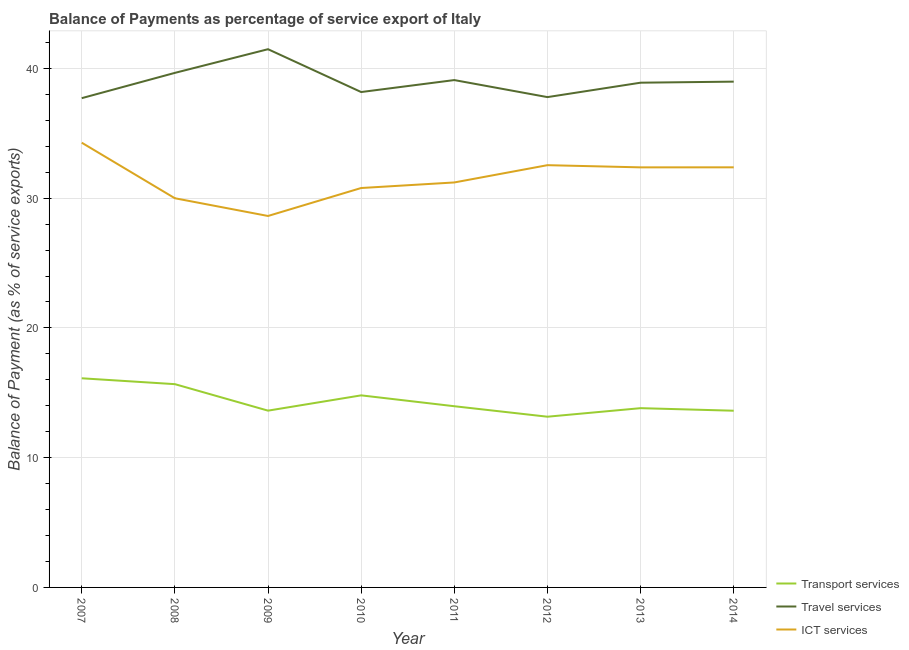Does the line corresponding to balance of payment of travel services intersect with the line corresponding to balance of payment of ict services?
Give a very brief answer. No. Is the number of lines equal to the number of legend labels?
Your response must be concise. Yes. What is the balance of payment of ict services in 2011?
Make the answer very short. 31.21. Across all years, what is the maximum balance of payment of transport services?
Your answer should be compact. 16.12. Across all years, what is the minimum balance of payment of transport services?
Offer a very short reply. 13.16. What is the total balance of payment of ict services in the graph?
Make the answer very short. 252.18. What is the difference between the balance of payment of ict services in 2009 and that in 2010?
Your answer should be very brief. -2.16. What is the difference between the balance of payment of transport services in 2007 and the balance of payment of travel services in 2014?
Offer a very short reply. -22.86. What is the average balance of payment of transport services per year?
Provide a short and direct response. 14.35. In the year 2014, what is the difference between the balance of payment of travel services and balance of payment of transport services?
Offer a terse response. 25.36. In how many years, is the balance of payment of ict services greater than 22 %?
Keep it short and to the point. 8. What is the ratio of the balance of payment of transport services in 2009 to that in 2014?
Give a very brief answer. 1. Is the difference between the balance of payment of transport services in 2008 and 2012 greater than the difference between the balance of payment of travel services in 2008 and 2012?
Provide a short and direct response. Yes. What is the difference between the highest and the second highest balance of payment of ict services?
Ensure brevity in your answer.  1.73. What is the difference between the highest and the lowest balance of payment of travel services?
Make the answer very short. 3.77. Is the sum of the balance of payment of ict services in 2010 and 2014 greater than the maximum balance of payment of travel services across all years?
Give a very brief answer. Yes. Does the balance of payment of ict services monotonically increase over the years?
Ensure brevity in your answer.  No. Is the balance of payment of ict services strictly less than the balance of payment of travel services over the years?
Offer a terse response. Yes. Does the graph contain grids?
Give a very brief answer. Yes. Where does the legend appear in the graph?
Your response must be concise. Bottom right. How many legend labels are there?
Your answer should be very brief. 3. What is the title of the graph?
Keep it short and to the point. Balance of Payments as percentage of service export of Italy. What is the label or title of the X-axis?
Give a very brief answer. Year. What is the label or title of the Y-axis?
Provide a short and direct response. Balance of Payment (as % of service exports). What is the Balance of Payment (as % of service exports) of Transport services in 2007?
Your answer should be very brief. 16.12. What is the Balance of Payment (as % of service exports) in Travel services in 2007?
Offer a very short reply. 37.71. What is the Balance of Payment (as % of service exports) of ICT services in 2007?
Make the answer very short. 34.28. What is the Balance of Payment (as % of service exports) of Transport services in 2008?
Provide a short and direct response. 15.67. What is the Balance of Payment (as % of service exports) in Travel services in 2008?
Your answer should be compact. 39.66. What is the Balance of Payment (as % of service exports) in ICT services in 2008?
Provide a succinct answer. 29.99. What is the Balance of Payment (as % of service exports) of Transport services in 2009?
Your answer should be compact. 13.62. What is the Balance of Payment (as % of service exports) of Travel services in 2009?
Give a very brief answer. 41.48. What is the Balance of Payment (as % of service exports) of ICT services in 2009?
Keep it short and to the point. 28.63. What is the Balance of Payment (as % of service exports) in Transport services in 2010?
Your response must be concise. 14.8. What is the Balance of Payment (as % of service exports) of Travel services in 2010?
Make the answer very short. 38.18. What is the Balance of Payment (as % of service exports) of ICT services in 2010?
Provide a short and direct response. 30.78. What is the Balance of Payment (as % of service exports) of Transport services in 2011?
Offer a terse response. 13.96. What is the Balance of Payment (as % of service exports) of Travel services in 2011?
Make the answer very short. 39.1. What is the Balance of Payment (as % of service exports) in ICT services in 2011?
Your answer should be compact. 31.21. What is the Balance of Payment (as % of service exports) in Transport services in 2012?
Provide a short and direct response. 13.16. What is the Balance of Payment (as % of service exports) in Travel services in 2012?
Your answer should be compact. 37.79. What is the Balance of Payment (as % of service exports) of ICT services in 2012?
Your answer should be compact. 32.54. What is the Balance of Payment (as % of service exports) in Transport services in 2013?
Your response must be concise. 13.82. What is the Balance of Payment (as % of service exports) in Travel services in 2013?
Ensure brevity in your answer.  38.9. What is the Balance of Payment (as % of service exports) in ICT services in 2013?
Keep it short and to the point. 32.37. What is the Balance of Payment (as % of service exports) in Transport services in 2014?
Keep it short and to the point. 13.62. What is the Balance of Payment (as % of service exports) in Travel services in 2014?
Your answer should be very brief. 38.98. What is the Balance of Payment (as % of service exports) of ICT services in 2014?
Offer a very short reply. 32.38. Across all years, what is the maximum Balance of Payment (as % of service exports) of Transport services?
Make the answer very short. 16.12. Across all years, what is the maximum Balance of Payment (as % of service exports) of Travel services?
Make the answer very short. 41.48. Across all years, what is the maximum Balance of Payment (as % of service exports) of ICT services?
Your answer should be compact. 34.28. Across all years, what is the minimum Balance of Payment (as % of service exports) in Transport services?
Your response must be concise. 13.16. Across all years, what is the minimum Balance of Payment (as % of service exports) of Travel services?
Give a very brief answer. 37.71. Across all years, what is the minimum Balance of Payment (as % of service exports) in ICT services?
Give a very brief answer. 28.63. What is the total Balance of Payment (as % of service exports) in Transport services in the graph?
Give a very brief answer. 114.77. What is the total Balance of Payment (as % of service exports) in Travel services in the graph?
Offer a very short reply. 311.79. What is the total Balance of Payment (as % of service exports) in ICT services in the graph?
Your response must be concise. 252.18. What is the difference between the Balance of Payment (as % of service exports) in Transport services in 2007 and that in 2008?
Make the answer very short. 0.45. What is the difference between the Balance of Payment (as % of service exports) of Travel services in 2007 and that in 2008?
Provide a succinct answer. -1.95. What is the difference between the Balance of Payment (as % of service exports) in ICT services in 2007 and that in 2008?
Your answer should be very brief. 4.28. What is the difference between the Balance of Payment (as % of service exports) of Transport services in 2007 and that in 2009?
Your answer should be very brief. 2.49. What is the difference between the Balance of Payment (as % of service exports) in Travel services in 2007 and that in 2009?
Ensure brevity in your answer.  -3.77. What is the difference between the Balance of Payment (as % of service exports) of ICT services in 2007 and that in 2009?
Your response must be concise. 5.65. What is the difference between the Balance of Payment (as % of service exports) in Transport services in 2007 and that in 2010?
Your answer should be very brief. 1.32. What is the difference between the Balance of Payment (as % of service exports) in Travel services in 2007 and that in 2010?
Your answer should be very brief. -0.47. What is the difference between the Balance of Payment (as % of service exports) in ICT services in 2007 and that in 2010?
Ensure brevity in your answer.  3.49. What is the difference between the Balance of Payment (as % of service exports) of Transport services in 2007 and that in 2011?
Offer a terse response. 2.15. What is the difference between the Balance of Payment (as % of service exports) in Travel services in 2007 and that in 2011?
Provide a short and direct response. -1.39. What is the difference between the Balance of Payment (as % of service exports) in ICT services in 2007 and that in 2011?
Offer a terse response. 3.06. What is the difference between the Balance of Payment (as % of service exports) in Transport services in 2007 and that in 2012?
Offer a very short reply. 2.96. What is the difference between the Balance of Payment (as % of service exports) in Travel services in 2007 and that in 2012?
Give a very brief answer. -0.08. What is the difference between the Balance of Payment (as % of service exports) in ICT services in 2007 and that in 2012?
Make the answer very short. 1.73. What is the difference between the Balance of Payment (as % of service exports) of Transport services in 2007 and that in 2013?
Offer a very short reply. 2.3. What is the difference between the Balance of Payment (as % of service exports) of Travel services in 2007 and that in 2013?
Your answer should be compact. -1.19. What is the difference between the Balance of Payment (as % of service exports) of ICT services in 2007 and that in 2013?
Your answer should be very brief. 1.9. What is the difference between the Balance of Payment (as % of service exports) in Transport services in 2007 and that in 2014?
Your answer should be very brief. 2.5. What is the difference between the Balance of Payment (as % of service exports) of Travel services in 2007 and that in 2014?
Provide a short and direct response. -1.27. What is the difference between the Balance of Payment (as % of service exports) in ICT services in 2007 and that in 2014?
Give a very brief answer. 1.9. What is the difference between the Balance of Payment (as % of service exports) in Transport services in 2008 and that in 2009?
Your answer should be very brief. 2.04. What is the difference between the Balance of Payment (as % of service exports) in Travel services in 2008 and that in 2009?
Your response must be concise. -1.82. What is the difference between the Balance of Payment (as % of service exports) in ICT services in 2008 and that in 2009?
Offer a very short reply. 1.37. What is the difference between the Balance of Payment (as % of service exports) of Transport services in 2008 and that in 2010?
Make the answer very short. 0.86. What is the difference between the Balance of Payment (as % of service exports) in Travel services in 2008 and that in 2010?
Offer a terse response. 1.48. What is the difference between the Balance of Payment (as % of service exports) of ICT services in 2008 and that in 2010?
Offer a very short reply. -0.79. What is the difference between the Balance of Payment (as % of service exports) of Transport services in 2008 and that in 2011?
Your answer should be compact. 1.7. What is the difference between the Balance of Payment (as % of service exports) in Travel services in 2008 and that in 2011?
Offer a terse response. 0.56. What is the difference between the Balance of Payment (as % of service exports) of ICT services in 2008 and that in 2011?
Provide a succinct answer. -1.22. What is the difference between the Balance of Payment (as % of service exports) of Transport services in 2008 and that in 2012?
Make the answer very short. 2.51. What is the difference between the Balance of Payment (as % of service exports) of Travel services in 2008 and that in 2012?
Provide a succinct answer. 1.87. What is the difference between the Balance of Payment (as % of service exports) in ICT services in 2008 and that in 2012?
Ensure brevity in your answer.  -2.55. What is the difference between the Balance of Payment (as % of service exports) of Transport services in 2008 and that in 2013?
Provide a succinct answer. 1.85. What is the difference between the Balance of Payment (as % of service exports) in Travel services in 2008 and that in 2013?
Ensure brevity in your answer.  0.76. What is the difference between the Balance of Payment (as % of service exports) in ICT services in 2008 and that in 2013?
Make the answer very short. -2.38. What is the difference between the Balance of Payment (as % of service exports) of Transport services in 2008 and that in 2014?
Ensure brevity in your answer.  2.05. What is the difference between the Balance of Payment (as % of service exports) of Travel services in 2008 and that in 2014?
Ensure brevity in your answer.  0.68. What is the difference between the Balance of Payment (as % of service exports) of ICT services in 2008 and that in 2014?
Offer a very short reply. -2.38. What is the difference between the Balance of Payment (as % of service exports) in Transport services in 2009 and that in 2010?
Offer a terse response. -1.18. What is the difference between the Balance of Payment (as % of service exports) in Travel services in 2009 and that in 2010?
Offer a very short reply. 3.3. What is the difference between the Balance of Payment (as % of service exports) of ICT services in 2009 and that in 2010?
Offer a terse response. -2.16. What is the difference between the Balance of Payment (as % of service exports) in Transport services in 2009 and that in 2011?
Ensure brevity in your answer.  -0.34. What is the difference between the Balance of Payment (as % of service exports) of Travel services in 2009 and that in 2011?
Offer a very short reply. 2.38. What is the difference between the Balance of Payment (as % of service exports) of ICT services in 2009 and that in 2011?
Make the answer very short. -2.58. What is the difference between the Balance of Payment (as % of service exports) in Transport services in 2009 and that in 2012?
Keep it short and to the point. 0.47. What is the difference between the Balance of Payment (as % of service exports) of Travel services in 2009 and that in 2012?
Provide a succinct answer. 3.69. What is the difference between the Balance of Payment (as % of service exports) of ICT services in 2009 and that in 2012?
Give a very brief answer. -3.92. What is the difference between the Balance of Payment (as % of service exports) in Transport services in 2009 and that in 2013?
Make the answer very short. -0.19. What is the difference between the Balance of Payment (as % of service exports) of Travel services in 2009 and that in 2013?
Keep it short and to the point. 2.58. What is the difference between the Balance of Payment (as % of service exports) of ICT services in 2009 and that in 2013?
Provide a succinct answer. -3.75. What is the difference between the Balance of Payment (as % of service exports) of Transport services in 2009 and that in 2014?
Provide a short and direct response. 0.01. What is the difference between the Balance of Payment (as % of service exports) in Travel services in 2009 and that in 2014?
Provide a short and direct response. 2.5. What is the difference between the Balance of Payment (as % of service exports) of ICT services in 2009 and that in 2014?
Your response must be concise. -3.75. What is the difference between the Balance of Payment (as % of service exports) in Transport services in 2010 and that in 2011?
Keep it short and to the point. 0.84. What is the difference between the Balance of Payment (as % of service exports) in Travel services in 2010 and that in 2011?
Give a very brief answer. -0.92. What is the difference between the Balance of Payment (as % of service exports) in ICT services in 2010 and that in 2011?
Offer a terse response. -0.43. What is the difference between the Balance of Payment (as % of service exports) of Transport services in 2010 and that in 2012?
Offer a terse response. 1.65. What is the difference between the Balance of Payment (as % of service exports) in Travel services in 2010 and that in 2012?
Provide a short and direct response. 0.39. What is the difference between the Balance of Payment (as % of service exports) of ICT services in 2010 and that in 2012?
Give a very brief answer. -1.76. What is the difference between the Balance of Payment (as % of service exports) in Transport services in 2010 and that in 2013?
Provide a short and direct response. 0.99. What is the difference between the Balance of Payment (as % of service exports) of Travel services in 2010 and that in 2013?
Your answer should be compact. -0.72. What is the difference between the Balance of Payment (as % of service exports) in ICT services in 2010 and that in 2013?
Your response must be concise. -1.59. What is the difference between the Balance of Payment (as % of service exports) in Transport services in 2010 and that in 2014?
Keep it short and to the point. 1.18. What is the difference between the Balance of Payment (as % of service exports) in Travel services in 2010 and that in 2014?
Provide a succinct answer. -0.8. What is the difference between the Balance of Payment (as % of service exports) in ICT services in 2010 and that in 2014?
Keep it short and to the point. -1.59. What is the difference between the Balance of Payment (as % of service exports) in Transport services in 2011 and that in 2012?
Your answer should be compact. 0.81. What is the difference between the Balance of Payment (as % of service exports) of Travel services in 2011 and that in 2012?
Ensure brevity in your answer.  1.31. What is the difference between the Balance of Payment (as % of service exports) in ICT services in 2011 and that in 2012?
Give a very brief answer. -1.33. What is the difference between the Balance of Payment (as % of service exports) in Transport services in 2011 and that in 2013?
Provide a succinct answer. 0.15. What is the difference between the Balance of Payment (as % of service exports) of Travel services in 2011 and that in 2013?
Offer a terse response. 0.2. What is the difference between the Balance of Payment (as % of service exports) of ICT services in 2011 and that in 2013?
Give a very brief answer. -1.16. What is the difference between the Balance of Payment (as % of service exports) in Transport services in 2011 and that in 2014?
Give a very brief answer. 0.35. What is the difference between the Balance of Payment (as % of service exports) of Travel services in 2011 and that in 2014?
Make the answer very short. 0.12. What is the difference between the Balance of Payment (as % of service exports) in ICT services in 2011 and that in 2014?
Keep it short and to the point. -1.17. What is the difference between the Balance of Payment (as % of service exports) of Transport services in 2012 and that in 2013?
Your response must be concise. -0.66. What is the difference between the Balance of Payment (as % of service exports) in Travel services in 2012 and that in 2013?
Provide a short and direct response. -1.11. What is the difference between the Balance of Payment (as % of service exports) of ICT services in 2012 and that in 2013?
Offer a very short reply. 0.17. What is the difference between the Balance of Payment (as % of service exports) of Transport services in 2012 and that in 2014?
Make the answer very short. -0.46. What is the difference between the Balance of Payment (as % of service exports) of Travel services in 2012 and that in 2014?
Offer a very short reply. -1.19. What is the difference between the Balance of Payment (as % of service exports) in ICT services in 2012 and that in 2014?
Offer a terse response. 0.17. What is the difference between the Balance of Payment (as % of service exports) in Transport services in 2013 and that in 2014?
Ensure brevity in your answer.  0.2. What is the difference between the Balance of Payment (as % of service exports) in Travel services in 2013 and that in 2014?
Your answer should be very brief. -0.08. What is the difference between the Balance of Payment (as % of service exports) in ICT services in 2013 and that in 2014?
Provide a short and direct response. -0. What is the difference between the Balance of Payment (as % of service exports) of Transport services in 2007 and the Balance of Payment (as % of service exports) of Travel services in 2008?
Provide a short and direct response. -23.54. What is the difference between the Balance of Payment (as % of service exports) of Transport services in 2007 and the Balance of Payment (as % of service exports) of ICT services in 2008?
Your answer should be very brief. -13.88. What is the difference between the Balance of Payment (as % of service exports) of Travel services in 2007 and the Balance of Payment (as % of service exports) of ICT services in 2008?
Ensure brevity in your answer.  7.71. What is the difference between the Balance of Payment (as % of service exports) of Transport services in 2007 and the Balance of Payment (as % of service exports) of Travel services in 2009?
Offer a very short reply. -25.36. What is the difference between the Balance of Payment (as % of service exports) of Transport services in 2007 and the Balance of Payment (as % of service exports) of ICT services in 2009?
Provide a succinct answer. -12.51. What is the difference between the Balance of Payment (as % of service exports) in Travel services in 2007 and the Balance of Payment (as % of service exports) in ICT services in 2009?
Offer a terse response. 9.08. What is the difference between the Balance of Payment (as % of service exports) of Transport services in 2007 and the Balance of Payment (as % of service exports) of Travel services in 2010?
Keep it short and to the point. -22.06. What is the difference between the Balance of Payment (as % of service exports) in Transport services in 2007 and the Balance of Payment (as % of service exports) in ICT services in 2010?
Offer a very short reply. -14.66. What is the difference between the Balance of Payment (as % of service exports) of Travel services in 2007 and the Balance of Payment (as % of service exports) of ICT services in 2010?
Offer a very short reply. 6.92. What is the difference between the Balance of Payment (as % of service exports) of Transport services in 2007 and the Balance of Payment (as % of service exports) of Travel services in 2011?
Ensure brevity in your answer.  -22.98. What is the difference between the Balance of Payment (as % of service exports) in Transport services in 2007 and the Balance of Payment (as % of service exports) in ICT services in 2011?
Provide a succinct answer. -15.09. What is the difference between the Balance of Payment (as % of service exports) of Travel services in 2007 and the Balance of Payment (as % of service exports) of ICT services in 2011?
Keep it short and to the point. 6.5. What is the difference between the Balance of Payment (as % of service exports) in Transport services in 2007 and the Balance of Payment (as % of service exports) in Travel services in 2012?
Provide a succinct answer. -21.67. What is the difference between the Balance of Payment (as % of service exports) of Transport services in 2007 and the Balance of Payment (as % of service exports) of ICT services in 2012?
Offer a very short reply. -16.42. What is the difference between the Balance of Payment (as % of service exports) in Travel services in 2007 and the Balance of Payment (as % of service exports) in ICT services in 2012?
Give a very brief answer. 5.16. What is the difference between the Balance of Payment (as % of service exports) in Transport services in 2007 and the Balance of Payment (as % of service exports) in Travel services in 2013?
Offer a very short reply. -22.78. What is the difference between the Balance of Payment (as % of service exports) of Transport services in 2007 and the Balance of Payment (as % of service exports) of ICT services in 2013?
Your answer should be compact. -16.26. What is the difference between the Balance of Payment (as % of service exports) of Travel services in 2007 and the Balance of Payment (as % of service exports) of ICT services in 2013?
Your response must be concise. 5.33. What is the difference between the Balance of Payment (as % of service exports) of Transport services in 2007 and the Balance of Payment (as % of service exports) of Travel services in 2014?
Make the answer very short. -22.86. What is the difference between the Balance of Payment (as % of service exports) in Transport services in 2007 and the Balance of Payment (as % of service exports) in ICT services in 2014?
Provide a succinct answer. -16.26. What is the difference between the Balance of Payment (as % of service exports) in Travel services in 2007 and the Balance of Payment (as % of service exports) in ICT services in 2014?
Your response must be concise. 5.33. What is the difference between the Balance of Payment (as % of service exports) in Transport services in 2008 and the Balance of Payment (as % of service exports) in Travel services in 2009?
Ensure brevity in your answer.  -25.81. What is the difference between the Balance of Payment (as % of service exports) of Transport services in 2008 and the Balance of Payment (as % of service exports) of ICT services in 2009?
Make the answer very short. -12.96. What is the difference between the Balance of Payment (as % of service exports) in Travel services in 2008 and the Balance of Payment (as % of service exports) in ICT services in 2009?
Give a very brief answer. 11.03. What is the difference between the Balance of Payment (as % of service exports) of Transport services in 2008 and the Balance of Payment (as % of service exports) of Travel services in 2010?
Provide a succinct answer. -22.51. What is the difference between the Balance of Payment (as % of service exports) in Transport services in 2008 and the Balance of Payment (as % of service exports) in ICT services in 2010?
Your answer should be very brief. -15.12. What is the difference between the Balance of Payment (as % of service exports) of Travel services in 2008 and the Balance of Payment (as % of service exports) of ICT services in 2010?
Keep it short and to the point. 8.87. What is the difference between the Balance of Payment (as % of service exports) of Transport services in 2008 and the Balance of Payment (as % of service exports) of Travel services in 2011?
Keep it short and to the point. -23.44. What is the difference between the Balance of Payment (as % of service exports) in Transport services in 2008 and the Balance of Payment (as % of service exports) in ICT services in 2011?
Keep it short and to the point. -15.54. What is the difference between the Balance of Payment (as % of service exports) of Travel services in 2008 and the Balance of Payment (as % of service exports) of ICT services in 2011?
Keep it short and to the point. 8.45. What is the difference between the Balance of Payment (as % of service exports) of Transport services in 2008 and the Balance of Payment (as % of service exports) of Travel services in 2012?
Your answer should be very brief. -22.12. What is the difference between the Balance of Payment (as % of service exports) in Transport services in 2008 and the Balance of Payment (as % of service exports) in ICT services in 2012?
Ensure brevity in your answer.  -16.88. What is the difference between the Balance of Payment (as % of service exports) in Travel services in 2008 and the Balance of Payment (as % of service exports) in ICT services in 2012?
Ensure brevity in your answer.  7.11. What is the difference between the Balance of Payment (as % of service exports) of Transport services in 2008 and the Balance of Payment (as % of service exports) of Travel services in 2013?
Make the answer very short. -23.23. What is the difference between the Balance of Payment (as % of service exports) of Transport services in 2008 and the Balance of Payment (as % of service exports) of ICT services in 2013?
Offer a very short reply. -16.71. What is the difference between the Balance of Payment (as % of service exports) in Travel services in 2008 and the Balance of Payment (as % of service exports) in ICT services in 2013?
Make the answer very short. 7.28. What is the difference between the Balance of Payment (as % of service exports) in Transport services in 2008 and the Balance of Payment (as % of service exports) in Travel services in 2014?
Offer a very short reply. -23.32. What is the difference between the Balance of Payment (as % of service exports) in Transport services in 2008 and the Balance of Payment (as % of service exports) in ICT services in 2014?
Make the answer very short. -16.71. What is the difference between the Balance of Payment (as % of service exports) in Travel services in 2008 and the Balance of Payment (as % of service exports) in ICT services in 2014?
Offer a very short reply. 7.28. What is the difference between the Balance of Payment (as % of service exports) in Transport services in 2009 and the Balance of Payment (as % of service exports) in Travel services in 2010?
Provide a short and direct response. -24.56. What is the difference between the Balance of Payment (as % of service exports) of Transport services in 2009 and the Balance of Payment (as % of service exports) of ICT services in 2010?
Your answer should be compact. -17.16. What is the difference between the Balance of Payment (as % of service exports) of Travel services in 2009 and the Balance of Payment (as % of service exports) of ICT services in 2010?
Your answer should be compact. 10.7. What is the difference between the Balance of Payment (as % of service exports) in Transport services in 2009 and the Balance of Payment (as % of service exports) in Travel services in 2011?
Offer a very short reply. -25.48. What is the difference between the Balance of Payment (as % of service exports) in Transport services in 2009 and the Balance of Payment (as % of service exports) in ICT services in 2011?
Provide a succinct answer. -17.59. What is the difference between the Balance of Payment (as % of service exports) of Travel services in 2009 and the Balance of Payment (as % of service exports) of ICT services in 2011?
Your response must be concise. 10.27. What is the difference between the Balance of Payment (as % of service exports) of Transport services in 2009 and the Balance of Payment (as % of service exports) of Travel services in 2012?
Ensure brevity in your answer.  -24.16. What is the difference between the Balance of Payment (as % of service exports) in Transport services in 2009 and the Balance of Payment (as % of service exports) in ICT services in 2012?
Offer a terse response. -18.92. What is the difference between the Balance of Payment (as % of service exports) in Travel services in 2009 and the Balance of Payment (as % of service exports) in ICT services in 2012?
Your answer should be compact. 8.94. What is the difference between the Balance of Payment (as % of service exports) in Transport services in 2009 and the Balance of Payment (as % of service exports) in Travel services in 2013?
Provide a short and direct response. -25.28. What is the difference between the Balance of Payment (as % of service exports) in Transport services in 2009 and the Balance of Payment (as % of service exports) in ICT services in 2013?
Ensure brevity in your answer.  -18.75. What is the difference between the Balance of Payment (as % of service exports) in Travel services in 2009 and the Balance of Payment (as % of service exports) in ICT services in 2013?
Keep it short and to the point. 9.11. What is the difference between the Balance of Payment (as % of service exports) in Transport services in 2009 and the Balance of Payment (as % of service exports) in Travel services in 2014?
Keep it short and to the point. -25.36. What is the difference between the Balance of Payment (as % of service exports) of Transport services in 2009 and the Balance of Payment (as % of service exports) of ICT services in 2014?
Offer a very short reply. -18.75. What is the difference between the Balance of Payment (as % of service exports) of Travel services in 2009 and the Balance of Payment (as % of service exports) of ICT services in 2014?
Your response must be concise. 9.1. What is the difference between the Balance of Payment (as % of service exports) of Transport services in 2010 and the Balance of Payment (as % of service exports) of Travel services in 2011?
Offer a very short reply. -24.3. What is the difference between the Balance of Payment (as % of service exports) of Transport services in 2010 and the Balance of Payment (as % of service exports) of ICT services in 2011?
Offer a very short reply. -16.41. What is the difference between the Balance of Payment (as % of service exports) of Travel services in 2010 and the Balance of Payment (as % of service exports) of ICT services in 2011?
Make the answer very short. 6.97. What is the difference between the Balance of Payment (as % of service exports) in Transport services in 2010 and the Balance of Payment (as % of service exports) in Travel services in 2012?
Ensure brevity in your answer.  -22.99. What is the difference between the Balance of Payment (as % of service exports) in Transport services in 2010 and the Balance of Payment (as % of service exports) in ICT services in 2012?
Ensure brevity in your answer.  -17.74. What is the difference between the Balance of Payment (as % of service exports) in Travel services in 2010 and the Balance of Payment (as % of service exports) in ICT services in 2012?
Make the answer very short. 5.64. What is the difference between the Balance of Payment (as % of service exports) in Transport services in 2010 and the Balance of Payment (as % of service exports) in Travel services in 2013?
Give a very brief answer. -24.1. What is the difference between the Balance of Payment (as % of service exports) in Transport services in 2010 and the Balance of Payment (as % of service exports) in ICT services in 2013?
Offer a terse response. -17.57. What is the difference between the Balance of Payment (as % of service exports) of Travel services in 2010 and the Balance of Payment (as % of service exports) of ICT services in 2013?
Provide a succinct answer. 5.81. What is the difference between the Balance of Payment (as % of service exports) of Transport services in 2010 and the Balance of Payment (as % of service exports) of Travel services in 2014?
Provide a succinct answer. -24.18. What is the difference between the Balance of Payment (as % of service exports) in Transport services in 2010 and the Balance of Payment (as % of service exports) in ICT services in 2014?
Offer a terse response. -17.57. What is the difference between the Balance of Payment (as % of service exports) in Travel services in 2010 and the Balance of Payment (as % of service exports) in ICT services in 2014?
Your answer should be very brief. 5.8. What is the difference between the Balance of Payment (as % of service exports) of Transport services in 2011 and the Balance of Payment (as % of service exports) of Travel services in 2012?
Provide a succinct answer. -23.82. What is the difference between the Balance of Payment (as % of service exports) of Transport services in 2011 and the Balance of Payment (as % of service exports) of ICT services in 2012?
Make the answer very short. -18.58. What is the difference between the Balance of Payment (as % of service exports) of Travel services in 2011 and the Balance of Payment (as % of service exports) of ICT services in 2012?
Provide a short and direct response. 6.56. What is the difference between the Balance of Payment (as % of service exports) of Transport services in 2011 and the Balance of Payment (as % of service exports) of Travel services in 2013?
Ensure brevity in your answer.  -24.94. What is the difference between the Balance of Payment (as % of service exports) in Transport services in 2011 and the Balance of Payment (as % of service exports) in ICT services in 2013?
Offer a terse response. -18.41. What is the difference between the Balance of Payment (as % of service exports) of Travel services in 2011 and the Balance of Payment (as % of service exports) of ICT services in 2013?
Ensure brevity in your answer.  6.73. What is the difference between the Balance of Payment (as % of service exports) in Transport services in 2011 and the Balance of Payment (as % of service exports) in Travel services in 2014?
Your response must be concise. -25.02. What is the difference between the Balance of Payment (as % of service exports) in Transport services in 2011 and the Balance of Payment (as % of service exports) in ICT services in 2014?
Provide a succinct answer. -18.41. What is the difference between the Balance of Payment (as % of service exports) of Travel services in 2011 and the Balance of Payment (as % of service exports) of ICT services in 2014?
Give a very brief answer. 6.72. What is the difference between the Balance of Payment (as % of service exports) of Transport services in 2012 and the Balance of Payment (as % of service exports) of Travel services in 2013?
Give a very brief answer. -25.74. What is the difference between the Balance of Payment (as % of service exports) of Transport services in 2012 and the Balance of Payment (as % of service exports) of ICT services in 2013?
Offer a terse response. -19.22. What is the difference between the Balance of Payment (as % of service exports) of Travel services in 2012 and the Balance of Payment (as % of service exports) of ICT services in 2013?
Keep it short and to the point. 5.41. What is the difference between the Balance of Payment (as % of service exports) of Transport services in 2012 and the Balance of Payment (as % of service exports) of Travel services in 2014?
Your response must be concise. -25.82. What is the difference between the Balance of Payment (as % of service exports) in Transport services in 2012 and the Balance of Payment (as % of service exports) in ICT services in 2014?
Keep it short and to the point. -19.22. What is the difference between the Balance of Payment (as % of service exports) in Travel services in 2012 and the Balance of Payment (as % of service exports) in ICT services in 2014?
Your response must be concise. 5.41. What is the difference between the Balance of Payment (as % of service exports) in Transport services in 2013 and the Balance of Payment (as % of service exports) in Travel services in 2014?
Keep it short and to the point. -25.17. What is the difference between the Balance of Payment (as % of service exports) of Transport services in 2013 and the Balance of Payment (as % of service exports) of ICT services in 2014?
Give a very brief answer. -18.56. What is the difference between the Balance of Payment (as % of service exports) of Travel services in 2013 and the Balance of Payment (as % of service exports) of ICT services in 2014?
Your answer should be very brief. 6.52. What is the average Balance of Payment (as % of service exports) of Transport services per year?
Make the answer very short. 14.35. What is the average Balance of Payment (as % of service exports) in Travel services per year?
Offer a terse response. 38.97. What is the average Balance of Payment (as % of service exports) in ICT services per year?
Keep it short and to the point. 31.52. In the year 2007, what is the difference between the Balance of Payment (as % of service exports) of Transport services and Balance of Payment (as % of service exports) of Travel services?
Ensure brevity in your answer.  -21.59. In the year 2007, what is the difference between the Balance of Payment (as % of service exports) in Transport services and Balance of Payment (as % of service exports) in ICT services?
Make the answer very short. -18.16. In the year 2007, what is the difference between the Balance of Payment (as % of service exports) in Travel services and Balance of Payment (as % of service exports) in ICT services?
Provide a short and direct response. 3.43. In the year 2008, what is the difference between the Balance of Payment (as % of service exports) in Transport services and Balance of Payment (as % of service exports) in Travel services?
Provide a short and direct response. -23.99. In the year 2008, what is the difference between the Balance of Payment (as % of service exports) of Transport services and Balance of Payment (as % of service exports) of ICT services?
Offer a terse response. -14.33. In the year 2008, what is the difference between the Balance of Payment (as % of service exports) of Travel services and Balance of Payment (as % of service exports) of ICT services?
Offer a very short reply. 9.66. In the year 2009, what is the difference between the Balance of Payment (as % of service exports) in Transport services and Balance of Payment (as % of service exports) in Travel services?
Give a very brief answer. -27.86. In the year 2009, what is the difference between the Balance of Payment (as % of service exports) of Transport services and Balance of Payment (as % of service exports) of ICT services?
Provide a succinct answer. -15. In the year 2009, what is the difference between the Balance of Payment (as % of service exports) of Travel services and Balance of Payment (as % of service exports) of ICT services?
Make the answer very short. 12.85. In the year 2010, what is the difference between the Balance of Payment (as % of service exports) in Transport services and Balance of Payment (as % of service exports) in Travel services?
Your answer should be compact. -23.38. In the year 2010, what is the difference between the Balance of Payment (as % of service exports) in Transport services and Balance of Payment (as % of service exports) in ICT services?
Provide a succinct answer. -15.98. In the year 2010, what is the difference between the Balance of Payment (as % of service exports) of Travel services and Balance of Payment (as % of service exports) of ICT services?
Keep it short and to the point. 7.4. In the year 2011, what is the difference between the Balance of Payment (as % of service exports) of Transport services and Balance of Payment (as % of service exports) of Travel services?
Provide a short and direct response. -25.14. In the year 2011, what is the difference between the Balance of Payment (as % of service exports) of Transport services and Balance of Payment (as % of service exports) of ICT services?
Keep it short and to the point. -17.25. In the year 2011, what is the difference between the Balance of Payment (as % of service exports) of Travel services and Balance of Payment (as % of service exports) of ICT services?
Provide a succinct answer. 7.89. In the year 2012, what is the difference between the Balance of Payment (as % of service exports) in Transport services and Balance of Payment (as % of service exports) in Travel services?
Make the answer very short. -24.63. In the year 2012, what is the difference between the Balance of Payment (as % of service exports) in Transport services and Balance of Payment (as % of service exports) in ICT services?
Your answer should be compact. -19.39. In the year 2012, what is the difference between the Balance of Payment (as % of service exports) of Travel services and Balance of Payment (as % of service exports) of ICT services?
Provide a succinct answer. 5.25. In the year 2013, what is the difference between the Balance of Payment (as % of service exports) of Transport services and Balance of Payment (as % of service exports) of Travel services?
Make the answer very short. -25.08. In the year 2013, what is the difference between the Balance of Payment (as % of service exports) of Transport services and Balance of Payment (as % of service exports) of ICT services?
Offer a terse response. -18.56. In the year 2013, what is the difference between the Balance of Payment (as % of service exports) in Travel services and Balance of Payment (as % of service exports) in ICT services?
Ensure brevity in your answer.  6.53. In the year 2014, what is the difference between the Balance of Payment (as % of service exports) of Transport services and Balance of Payment (as % of service exports) of Travel services?
Offer a very short reply. -25.36. In the year 2014, what is the difference between the Balance of Payment (as % of service exports) of Transport services and Balance of Payment (as % of service exports) of ICT services?
Offer a very short reply. -18.76. In the year 2014, what is the difference between the Balance of Payment (as % of service exports) in Travel services and Balance of Payment (as % of service exports) in ICT services?
Your response must be concise. 6.6. What is the ratio of the Balance of Payment (as % of service exports) of Transport services in 2007 to that in 2008?
Your answer should be very brief. 1.03. What is the ratio of the Balance of Payment (as % of service exports) of Travel services in 2007 to that in 2008?
Provide a succinct answer. 0.95. What is the ratio of the Balance of Payment (as % of service exports) in ICT services in 2007 to that in 2008?
Your answer should be compact. 1.14. What is the ratio of the Balance of Payment (as % of service exports) in Transport services in 2007 to that in 2009?
Provide a short and direct response. 1.18. What is the ratio of the Balance of Payment (as % of service exports) in Travel services in 2007 to that in 2009?
Provide a short and direct response. 0.91. What is the ratio of the Balance of Payment (as % of service exports) of ICT services in 2007 to that in 2009?
Your answer should be very brief. 1.2. What is the ratio of the Balance of Payment (as % of service exports) in Transport services in 2007 to that in 2010?
Your answer should be very brief. 1.09. What is the ratio of the Balance of Payment (as % of service exports) of Travel services in 2007 to that in 2010?
Keep it short and to the point. 0.99. What is the ratio of the Balance of Payment (as % of service exports) of ICT services in 2007 to that in 2010?
Offer a terse response. 1.11. What is the ratio of the Balance of Payment (as % of service exports) of Transport services in 2007 to that in 2011?
Make the answer very short. 1.15. What is the ratio of the Balance of Payment (as % of service exports) of Travel services in 2007 to that in 2011?
Keep it short and to the point. 0.96. What is the ratio of the Balance of Payment (as % of service exports) in ICT services in 2007 to that in 2011?
Your answer should be very brief. 1.1. What is the ratio of the Balance of Payment (as % of service exports) in Transport services in 2007 to that in 2012?
Your answer should be very brief. 1.23. What is the ratio of the Balance of Payment (as % of service exports) in ICT services in 2007 to that in 2012?
Your response must be concise. 1.05. What is the ratio of the Balance of Payment (as % of service exports) in Travel services in 2007 to that in 2013?
Give a very brief answer. 0.97. What is the ratio of the Balance of Payment (as % of service exports) in ICT services in 2007 to that in 2013?
Make the answer very short. 1.06. What is the ratio of the Balance of Payment (as % of service exports) of Transport services in 2007 to that in 2014?
Keep it short and to the point. 1.18. What is the ratio of the Balance of Payment (as % of service exports) in Travel services in 2007 to that in 2014?
Your response must be concise. 0.97. What is the ratio of the Balance of Payment (as % of service exports) of ICT services in 2007 to that in 2014?
Give a very brief answer. 1.06. What is the ratio of the Balance of Payment (as % of service exports) of Transport services in 2008 to that in 2009?
Your response must be concise. 1.15. What is the ratio of the Balance of Payment (as % of service exports) in Travel services in 2008 to that in 2009?
Offer a very short reply. 0.96. What is the ratio of the Balance of Payment (as % of service exports) in ICT services in 2008 to that in 2009?
Provide a succinct answer. 1.05. What is the ratio of the Balance of Payment (as % of service exports) of Transport services in 2008 to that in 2010?
Give a very brief answer. 1.06. What is the ratio of the Balance of Payment (as % of service exports) of Travel services in 2008 to that in 2010?
Give a very brief answer. 1.04. What is the ratio of the Balance of Payment (as % of service exports) in ICT services in 2008 to that in 2010?
Offer a very short reply. 0.97. What is the ratio of the Balance of Payment (as % of service exports) of Transport services in 2008 to that in 2011?
Your response must be concise. 1.12. What is the ratio of the Balance of Payment (as % of service exports) in Travel services in 2008 to that in 2011?
Keep it short and to the point. 1.01. What is the ratio of the Balance of Payment (as % of service exports) of Transport services in 2008 to that in 2012?
Your answer should be compact. 1.19. What is the ratio of the Balance of Payment (as % of service exports) in Travel services in 2008 to that in 2012?
Offer a very short reply. 1.05. What is the ratio of the Balance of Payment (as % of service exports) of ICT services in 2008 to that in 2012?
Offer a very short reply. 0.92. What is the ratio of the Balance of Payment (as % of service exports) of Transport services in 2008 to that in 2013?
Your answer should be very brief. 1.13. What is the ratio of the Balance of Payment (as % of service exports) in Travel services in 2008 to that in 2013?
Keep it short and to the point. 1.02. What is the ratio of the Balance of Payment (as % of service exports) in ICT services in 2008 to that in 2013?
Make the answer very short. 0.93. What is the ratio of the Balance of Payment (as % of service exports) of Transport services in 2008 to that in 2014?
Your answer should be very brief. 1.15. What is the ratio of the Balance of Payment (as % of service exports) of Travel services in 2008 to that in 2014?
Offer a terse response. 1.02. What is the ratio of the Balance of Payment (as % of service exports) in ICT services in 2008 to that in 2014?
Provide a short and direct response. 0.93. What is the ratio of the Balance of Payment (as % of service exports) in Transport services in 2009 to that in 2010?
Keep it short and to the point. 0.92. What is the ratio of the Balance of Payment (as % of service exports) of Travel services in 2009 to that in 2010?
Offer a terse response. 1.09. What is the ratio of the Balance of Payment (as % of service exports) in ICT services in 2009 to that in 2010?
Your answer should be very brief. 0.93. What is the ratio of the Balance of Payment (as % of service exports) in Transport services in 2009 to that in 2011?
Keep it short and to the point. 0.98. What is the ratio of the Balance of Payment (as % of service exports) in Travel services in 2009 to that in 2011?
Keep it short and to the point. 1.06. What is the ratio of the Balance of Payment (as % of service exports) in ICT services in 2009 to that in 2011?
Provide a short and direct response. 0.92. What is the ratio of the Balance of Payment (as % of service exports) in Transport services in 2009 to that in 2012?
Ensure brevity in your answer.  1.04. What is the ratio of the Balance of Payment (as % of service exports) of Travel services in 2009 to that in 2012?
Provide a succinct answer. 1.1. What is the ratio of the Balance of Payment (as % of service exports) of ICT services in 2009 to that in 2012?
Ensure brevity in your answer.  0.88. What is the ratio of the Balance of Payment (as % of service exports) of Transport services in 2009 to that in 2013?
Provide a short and direct response. 0.99. What is the ratio of the Balance of Payment (as % of service exports) of Travel services in 2009 to that in 2013?
Ensure brevity in your answer.  1.07. What is the ratio of the Balance of Payment (as % of service exports) in ICT services in 2009 to that in 2013?
Make the answer very short. 0.88. What is the ratio of the Balance of Payment (as % of service exports) in Transport services in 2009 to that in 2014?
Offer a very short reply. 1. What is the ratio of the Balance of Payment (as % of service exports) in Travel services in 2009 to that in 2014?
Make the answer very short. 1.06. What is the ratio of the Balance of Payment (as % of service exports) of ICT services in 2009 to that in 2014?
Offer a terse response. 0.88. What is the ratio of the Balance of Payment (as % of service exports) in Transport services in 2010 to that in 2011?
Make the answer very short. 1.06. What is the ratio of the Balance of Payment (as % of service exports) of Travel services in 2010 to that in 2011?
Provide a short and direct response. 0.98. What is the ratio of the Balance of Payment (as % of service exports) of ICT services in 2010 to that in 2011?
Offer a very short reply. 0.99. What is the ratio of the Balance of Payment (as % of service exports) of Transport services in 2010 to that in 2012?
Offer a very short reply. 1.13. What is the ratio of the Balance of Payment (as % of service exports) in Travel services in 2010 to that in 2012?
Your answer should be very brief. 1.01. What is the ratio of the Balance of Payment (as % of service exports) in ICT services in 2010 to that in 2012?
Make the answer very short. 0.95. What is the ratio of the Balance of Payment (as % of service exports) of Transport services in 2010 to that in 2013?
Ensure brevity in your answer.  1.07. What is the ratio of the Balance of Payment (as % of service exports) in Travel services in 2010 to that in 2013?
Your answer should be very brief. 0.98. What is the ratio of the Balance of Payment (as % of service exports) in ICT services in 2010 to that in 2013?
Provide a short and direct response. 0.95. What is the ratio of the Balance of Payment (as % of service exports) in Transport services in 2010 to that in 2014?
Your answer should be very brief. 1.09. What is the ratio of the Balance of Payment (as % of service exports) of Travel services in 2010 to that in 2014?
Ensure brevity in your answer.  0.98. What is the ratio of the Balance of Payment (as % of service exports) in ICT services in 2010 to that in 2014?
Keep it short and to the point. 0.95. What is the ratio of the Balance of Payment (as % of service exports) of Transport services in 2011 to that in 2012?
Your answer should be compact. 1.06. What is the ratio of the Balance of Payment (as % of service exports) of Travel services in 2011 to that in 2012?
Ensure brevity in your answer.  1.03. What is the ratio of the Balance of Payment (as % of service exports) of ICT services in 2011 to that in 2012?
Ensure brevity in your answer.  0.96. What is the ratio of the Balance of Payment (as % of service exports) in Transport services in 2011 to that in 2013?
Your answer should be very brief. 1.01. What is the ratio of the Balance of Payment (as % of service exports) in ICT services in 2011 to that in 2013?
Your answer should be compact. 0.96. What is the ratio of the Balance of Payment (as % of service exports) in Transport services in 2011 to that in 2014?
Provide a succinct answer. 1.03. What is the ratio of the Balance of Payment (as % of service exports) of Travel services in 2011 to that in 2014?
Provide a succinct answer. 1. What is the ratio of the Balance of Payment (as % of service exports) of Transport services in 2012 to that in 2013?
Give a very brief answer. 0.95. What is the ratio of the Balance of Payment (as % of service exports) of Travel services in 2012 to that in 2013?
Your answer should be compact. 0.97. What is the ratio of the Balance of Payment (as % of service exports) of ICT services in 2012 to that in 2013?
Offer a terse response. 1.01. What is the ratio of the Balance of Payment (as % of service exports) in Transport services in 2012 to that in 2014?
Give a very brief answer. 0.97. What is the ratio of the Balance of Payment (as % of service exports) in Travel services in 2012 to that in 2014?
Your response must be concise. 0.97. What is the ratio of the Balance of Payment (as % of service exports) in ICT services in 2012 to that in 2014?
Make the answer very short. 1.01. What is the ratio of the Balance of Payment (as % of service exports) in Transport services in 2013 to that in 2014?
Provide a short and direct response. 1.01. What is the difference between the highest and the second highest Balance of Payment (as % of service exports) of Transport services?
Your response must be concise. 0.45. What is the difference between the highest and the second highest Balance of Payment (as % of service exports) in Travel services?
Your response must be concise. 1.82. What is the difference between the highest and the second highest Balance of Payment (as % of service exports) in ICT services?
Make the answer very short. 1.73. What is the difference between the highest and the lowest Balance of Payment (as % of service exports) of Transport services?
Your response must be concise. 2.96. What is the difference between the highest and the lowest Balance of Payment (as % of service exports) of Travel services?
Your answer should be very brief. 3.77. What is the difference between the highest and the lowest Balance of Payment (as % of service exports) in ICT services?
Your response must be concise. 5.65. 